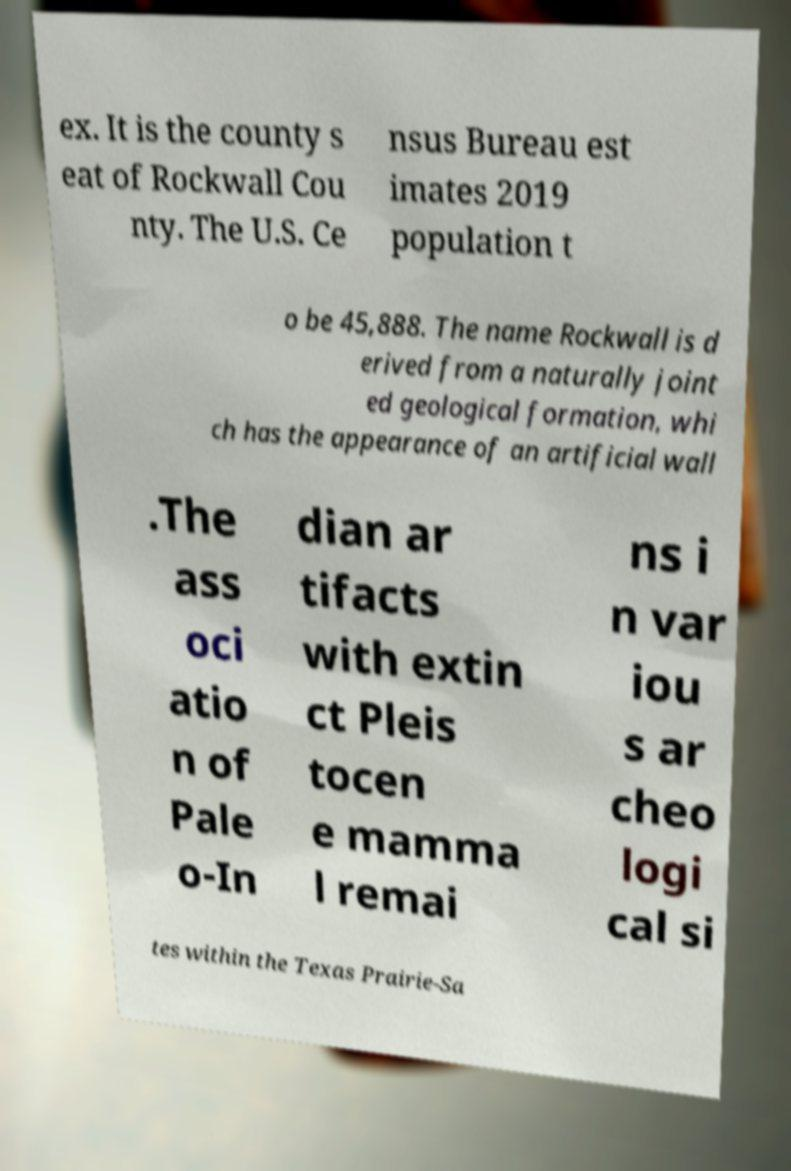I need the written content from this picture converted into text. Can you do that? ex. It is the county s eat of Rockwall Cou nty. The U.S. Ce nsus Bureau est imates 2019 population t o be 45,888. The name Rockwall is d erived from a naturally joint ed geological formation, whi ch has the appearance of an artificial wall .The ass oci atio n of Pale o-In dian ar tifacts with extin ct Pleis tocen e mamma l remai ns i n var iou s ar cheo logi cal si tes within the Texas Prairie-Sa 